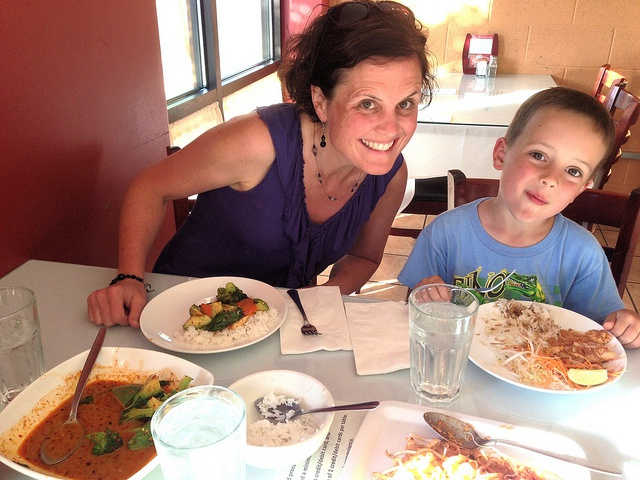Describe the objects in this image and their specific colors. I can see dining table in brown, ivory, tan, and gray tones, people in brown, black, and maroon tones, people in brown, salmon, gray, and darkgray tones, bowl in brown, maroon, tan, and orange tones, and dining table in brown, ivory, tan, and darkgray tones in this image. 